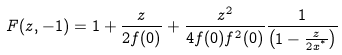<formula> <loc_0><loc_0><loc_500><loc_500>F ( z , - 1 ) = 1 + \frac { z } { 2 f ( 0 ) } + \frac { z ^ { 2 } } { 4 f ( 0 ) f ^ { 2 } ( 0 ) } \frac { 1 } { \left ( 1 - \frac { z } { 2 x ^ { ^ { * } } } \right ) }</formula> 